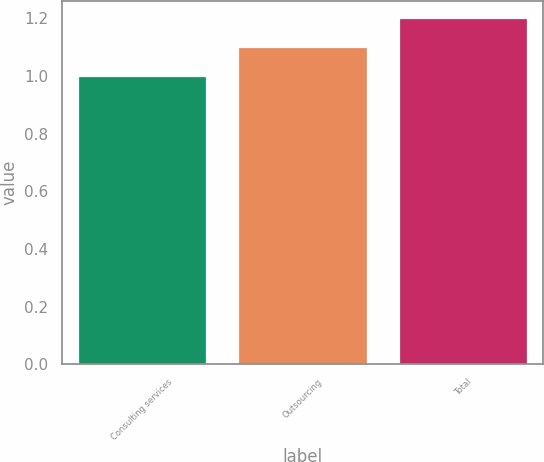Convert chart to OTSL. <chart><loc_0><loc_0><loc_500><loc_500><bar_chart><fcel>Consulting services<fcel>Outsourcing<fcel>Total<nl><fcel>1<fcel>1.1<fcel>1.2<nl></chart> 